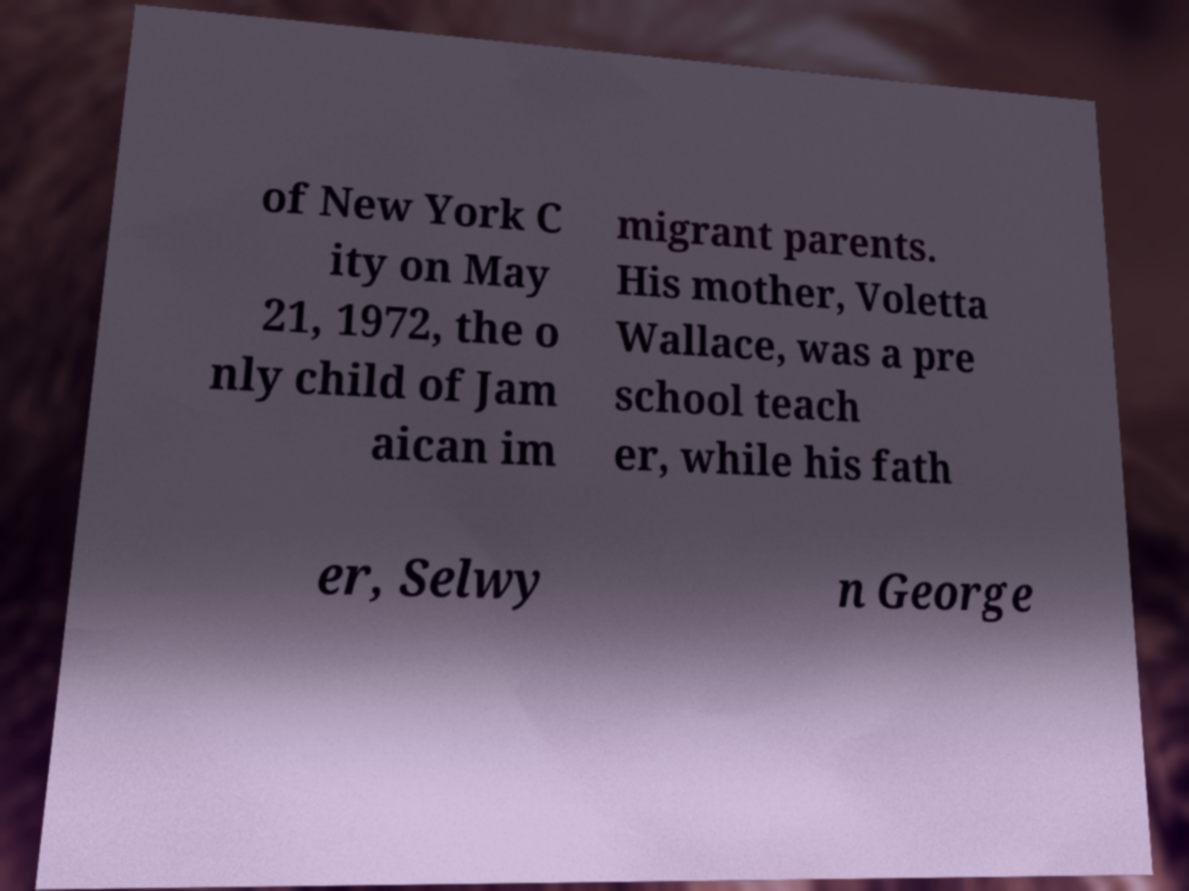Could you extract and type out the text from this image? of New York C ity on May 21, 1972, the o nly child of Jam aican im migrant parents. His mother, Voletta Wallace, was a pre school teach er, while his fath er, Selwy n George 